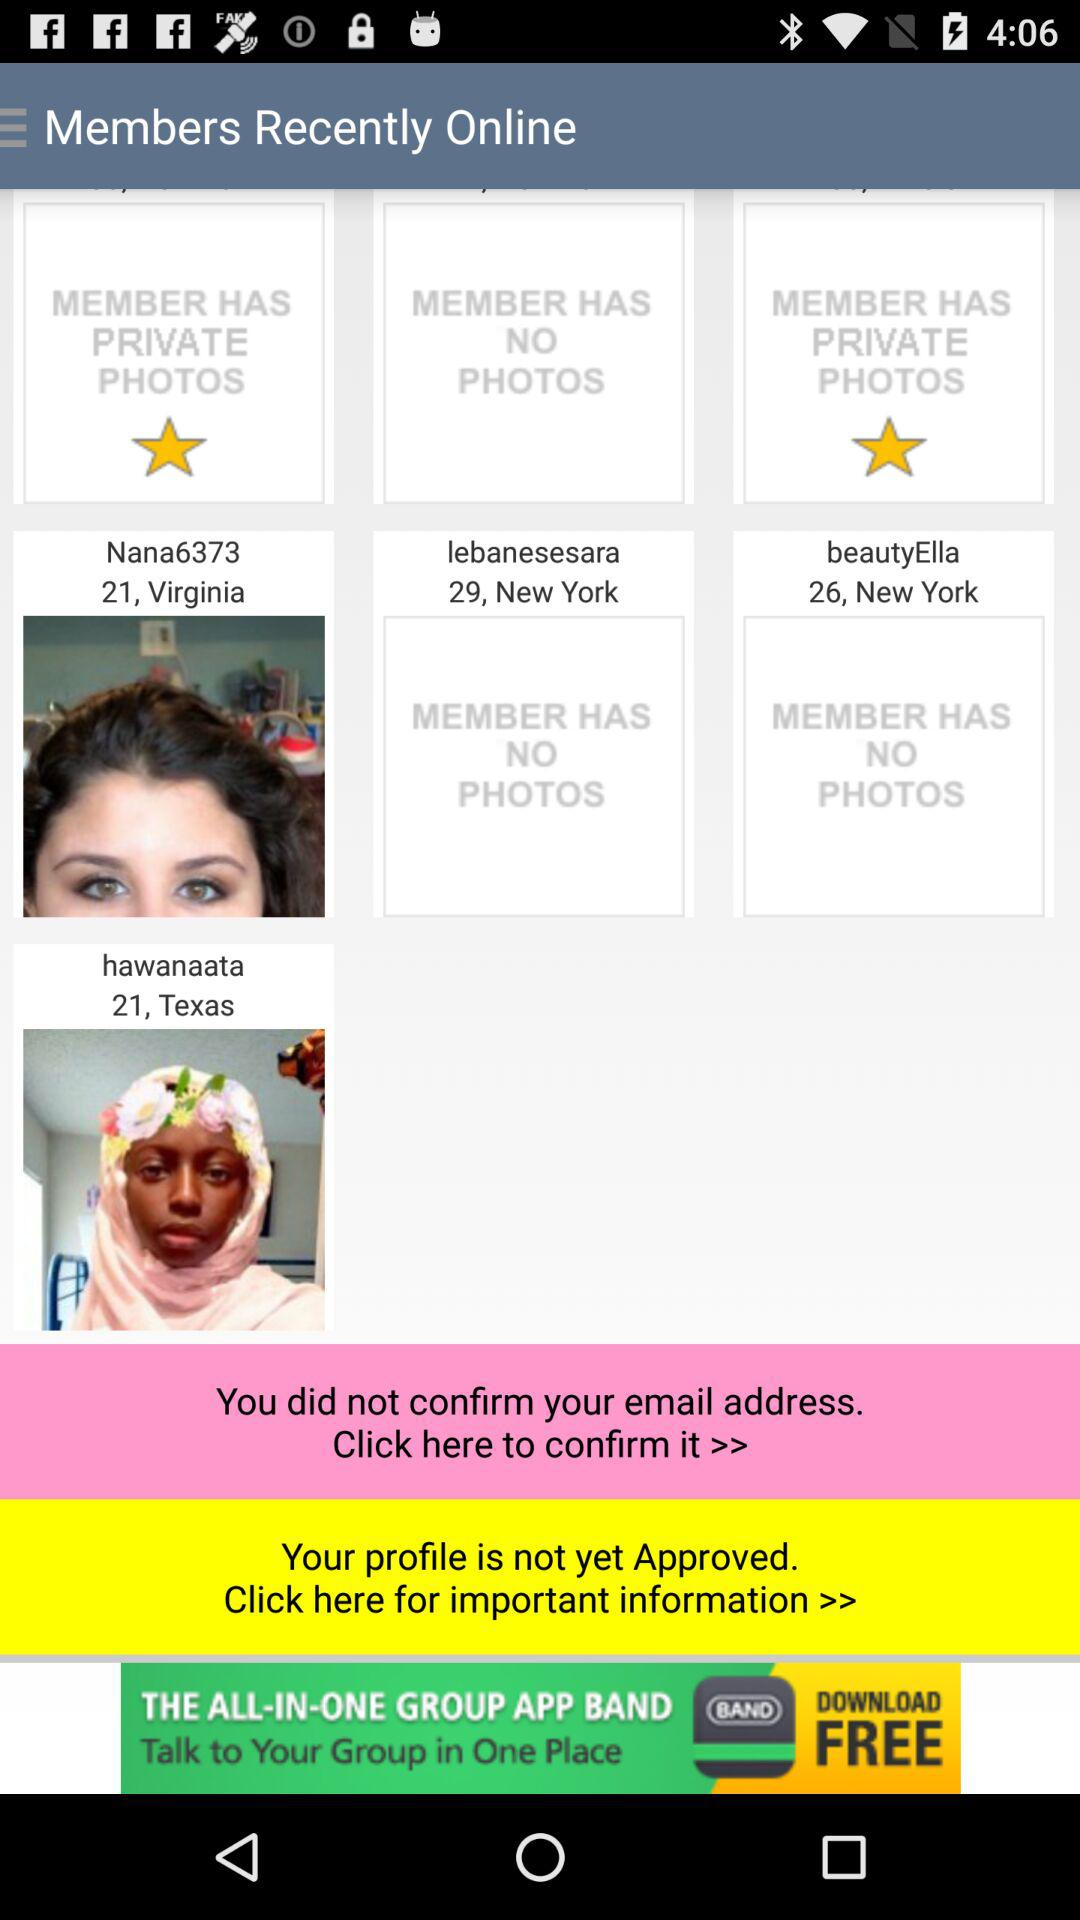In which city does "beautyElla" live? "beautyElla" lives in New York. 